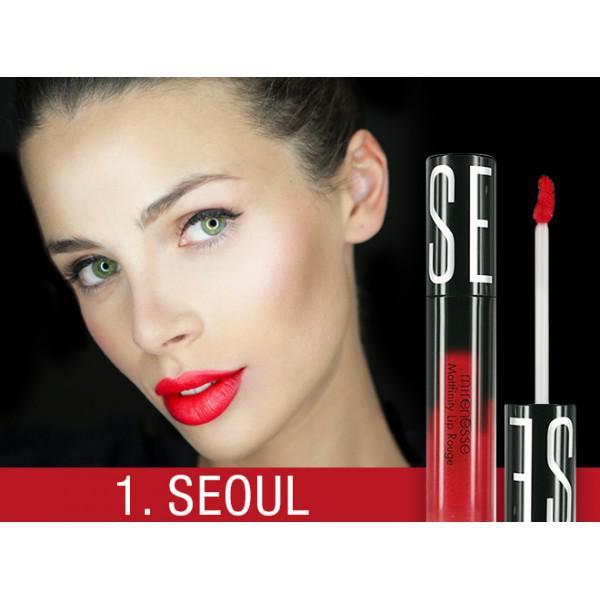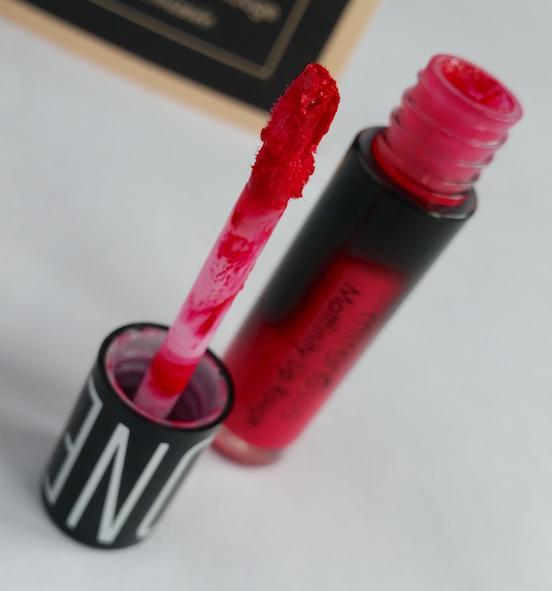The first image is the image on the left, the second image is the image on the right. Given the left and right images, does the statement "The woman's eyes can be seen in one of the images" hold true? Answer yes or no. Yes. The first image is the image on the left, the second image is the image on the right. For the images displayed, is the sentence "A woman's teeth are visible in at least one of the images." factually correct? Answer yes or no. Yes. 